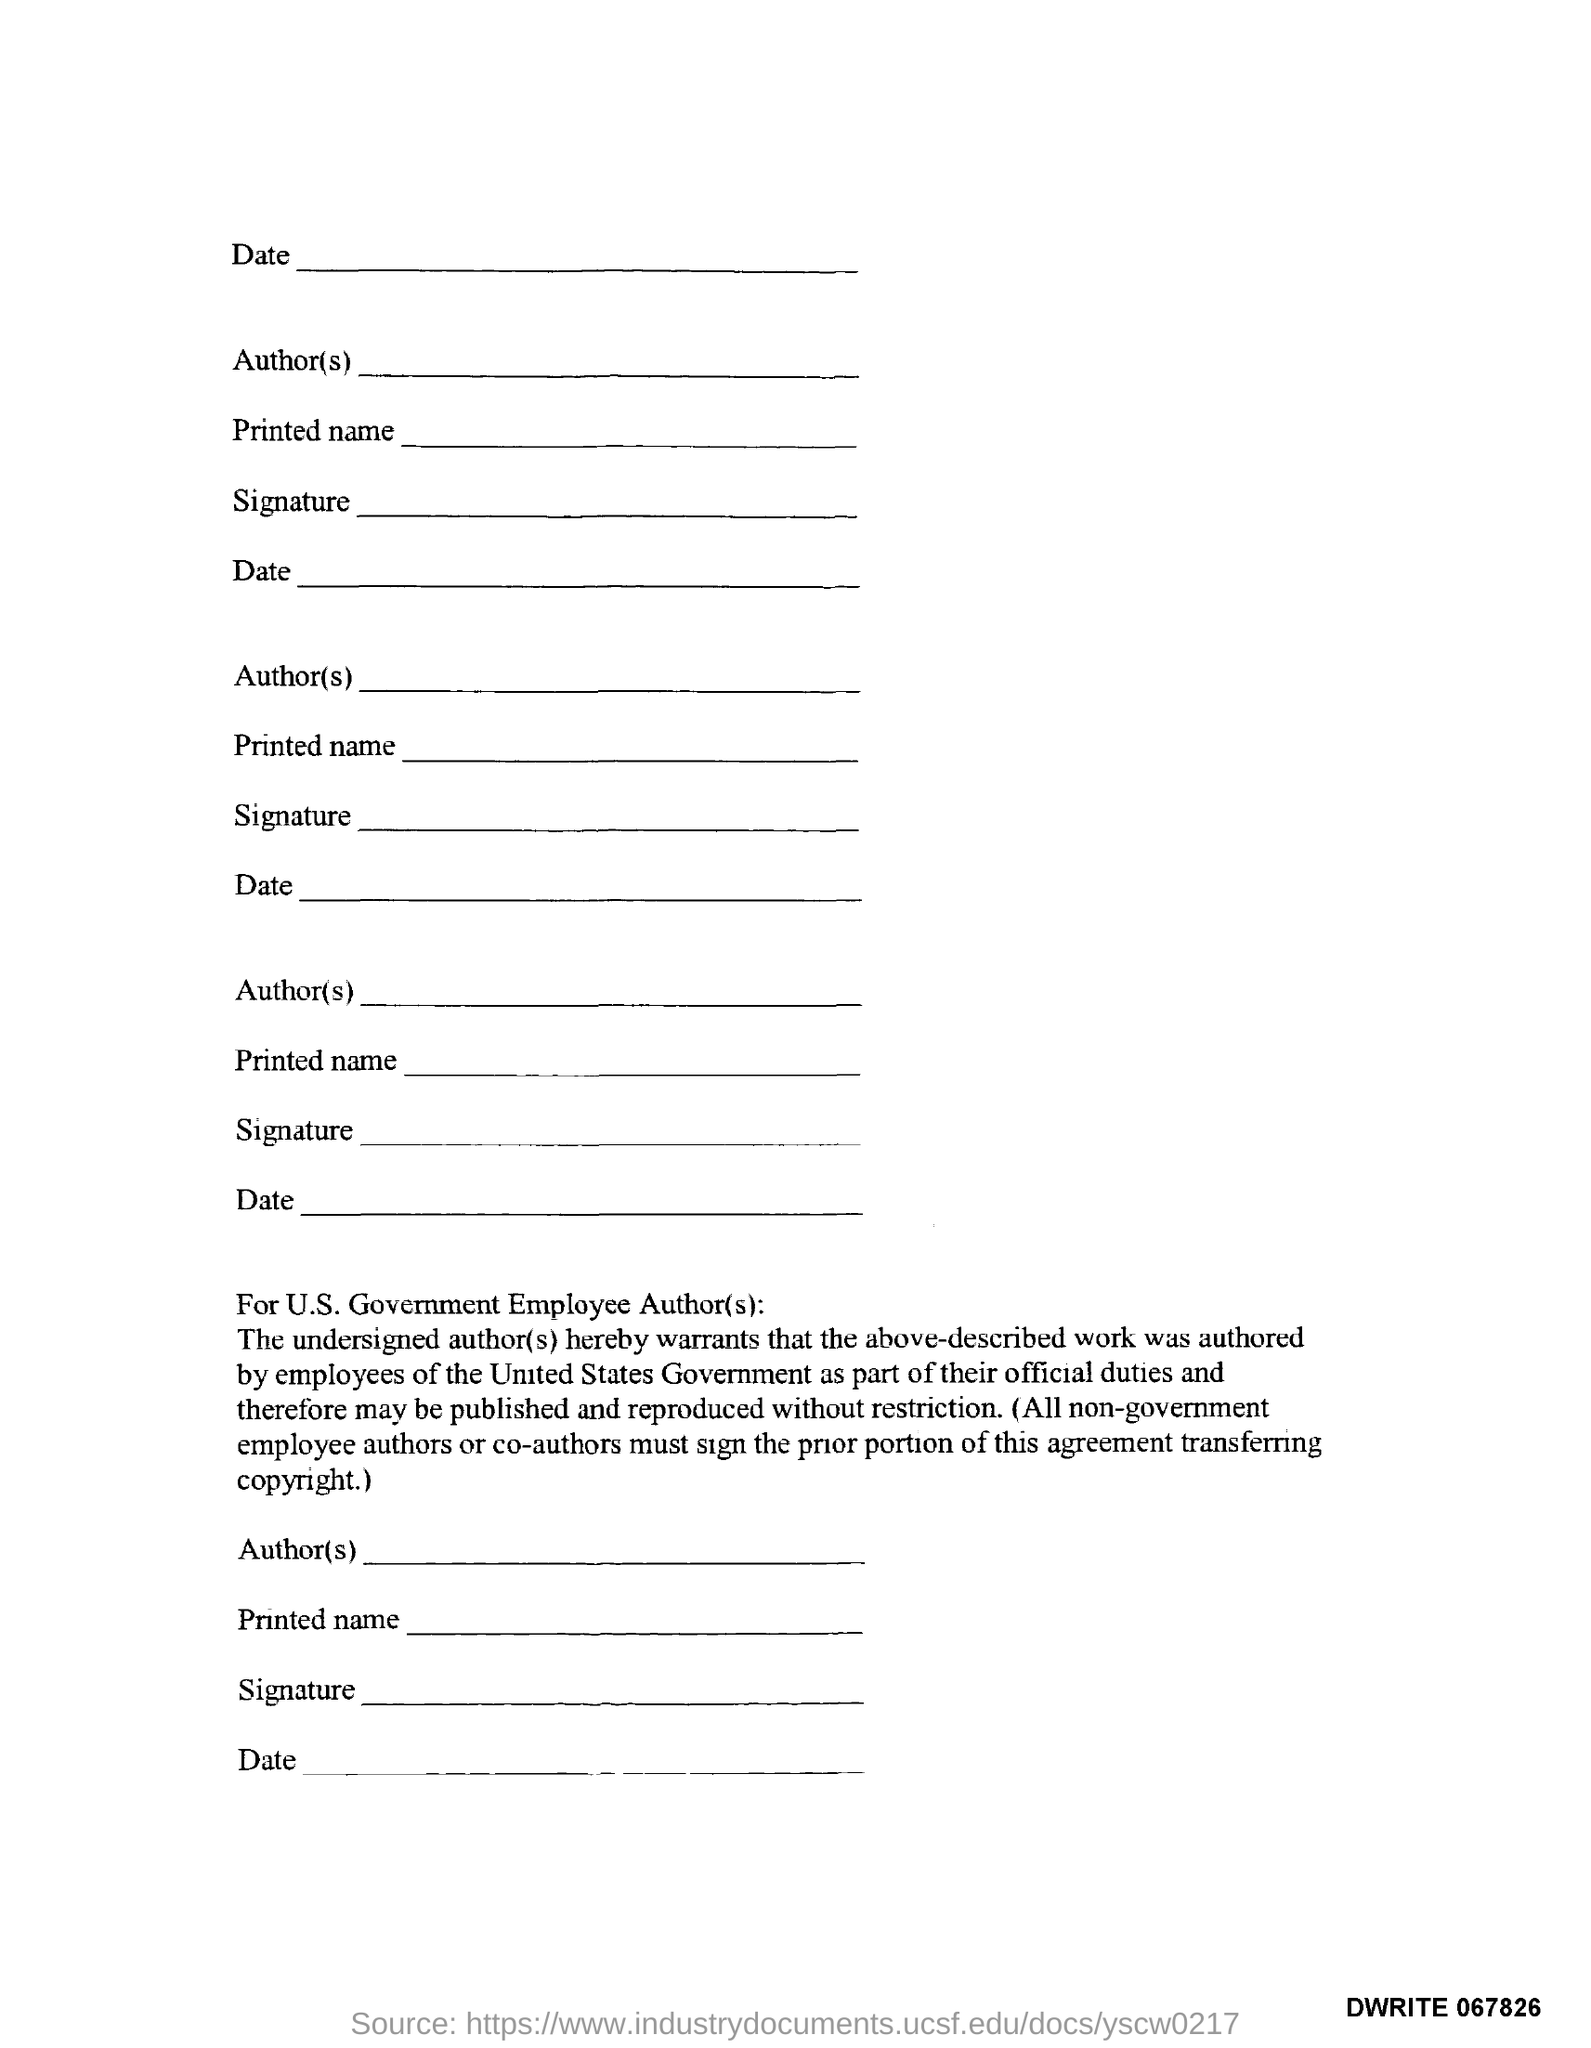What is the Document Number?
Your answer should be very brief. DWRITE 067826. 